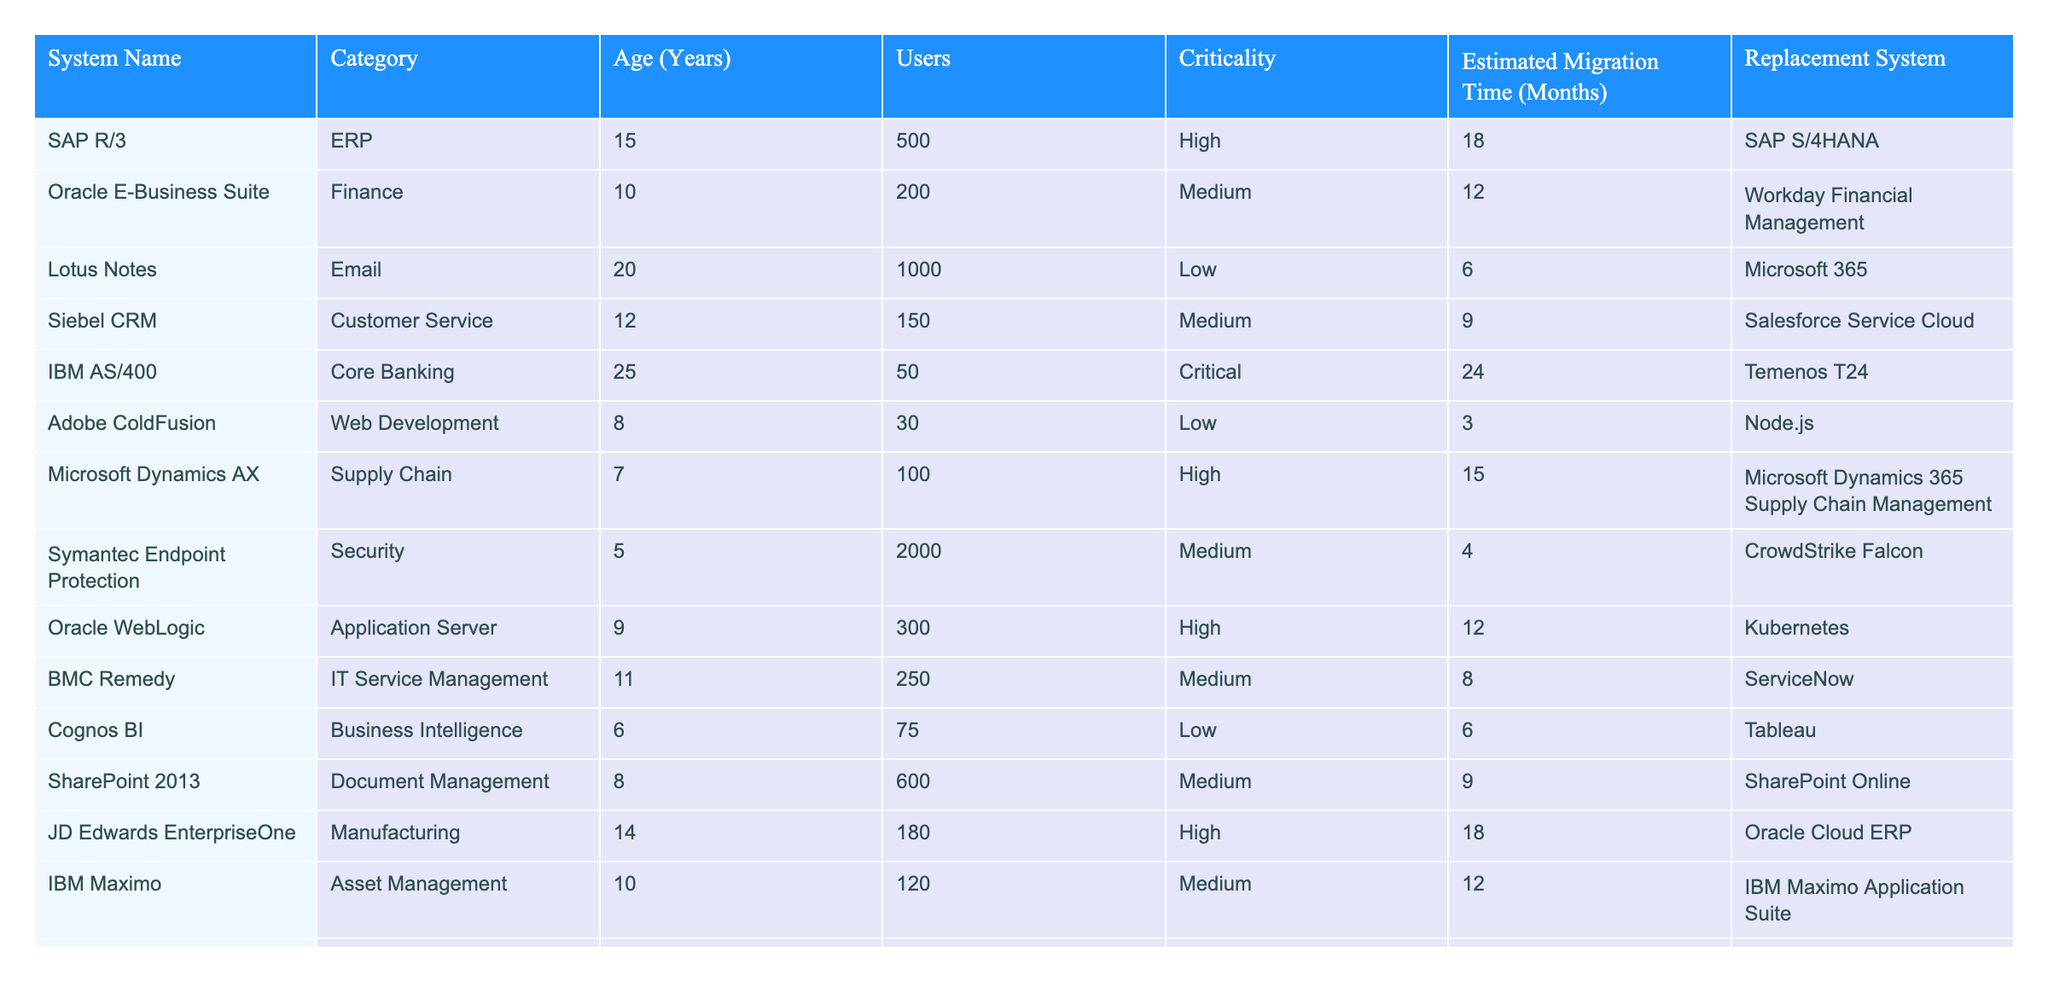What is the system with the highest criticality level? By examining the "Criticality" column, we see that "IBM AS/400" is labeled as "Critical," which is the highest level in the table.
Answer: IBM AS/400 How many users are there for Oracle E-Business Suite? Looking at the "Users" column, the entry for "Oracle E-Business Suite" shows that there are 200 users.
Answer: 200 Which system has the longest estimated migration time? Checking the "Estimated Migration Time (Months)" column, "IBM AS/400" has the longest migration time of 24 months.
Answer: 24 months What is the average age of the systems listed? To find the average age, we sum the ages of all systems (15 + 10 + 20 + 12 + 25 + 8 + 7 + 5 + 9 + 11 + 6 + 8 + 14 + 10 =  8.928) and divide by the total number of systems (14), resulting in an average age of approximately 12.07 years.
Answer: 12.07 years Is there a system that requires less than 5 months to migrate? By reviewing the "Estimated Migration Time (Months)" column, "Adobe ColdFusion" and "Symantec Endpoint Protection" both require only 3 and 4 months, respectively, which confirms the existence of such systems.
Answer: Yes Which two systems have the same criticality level of Medium? We look through the table and notice that "Oracle E-Business Suite," "Siebel CRM," "BMC Remedy," and "IBM Maximo" are marked as Medium. This means there are at least four systems with the same criticality level of Medium.
Answer: Oracle E-Business Suite, Siebel CRM, BMC Remedy, IBM Maximo What is the total estimated migration time of all High criticality systems? First, identify the systems with High criticality: "SAP R/3," "Microsoft Dynamics AX," "JD Edwards EnterpriseOne," and "PeopleSoft." The migration times are 18, 15, 18, and 15 months respectively. Summing these values gives us 66 months (18 + 15 + 18 + 15 = 66).
Answer: 66 months Which replacement system has the most legacy systems transitioning to it? By counting the frequency of replacement systems in the "Replacement System" column, we identify that "Workday" has two legacy systems transitioning to it: "Oracle E-Business Suite" and "PeopleSoft".
Answer: Workday Is "Lotus Notes" older than "Adobe ColdFusion"? Comparing the "Age (Years)" column, "Lotus Notes" is 20 years old while "Adobe ColdFusion" is 8 years old, confirming that "Lotus Notes" is indeed older.
Answer: Yes What is the system with the least users that also has a High criticality rating? Scanning the data, "IBM AS/400" has 50 users, which is the least among the systems with High criticality ("SAP R/3," "Microsoft Dynamics AX," and "PeopleSoft").
Answer: IBM AS/400 